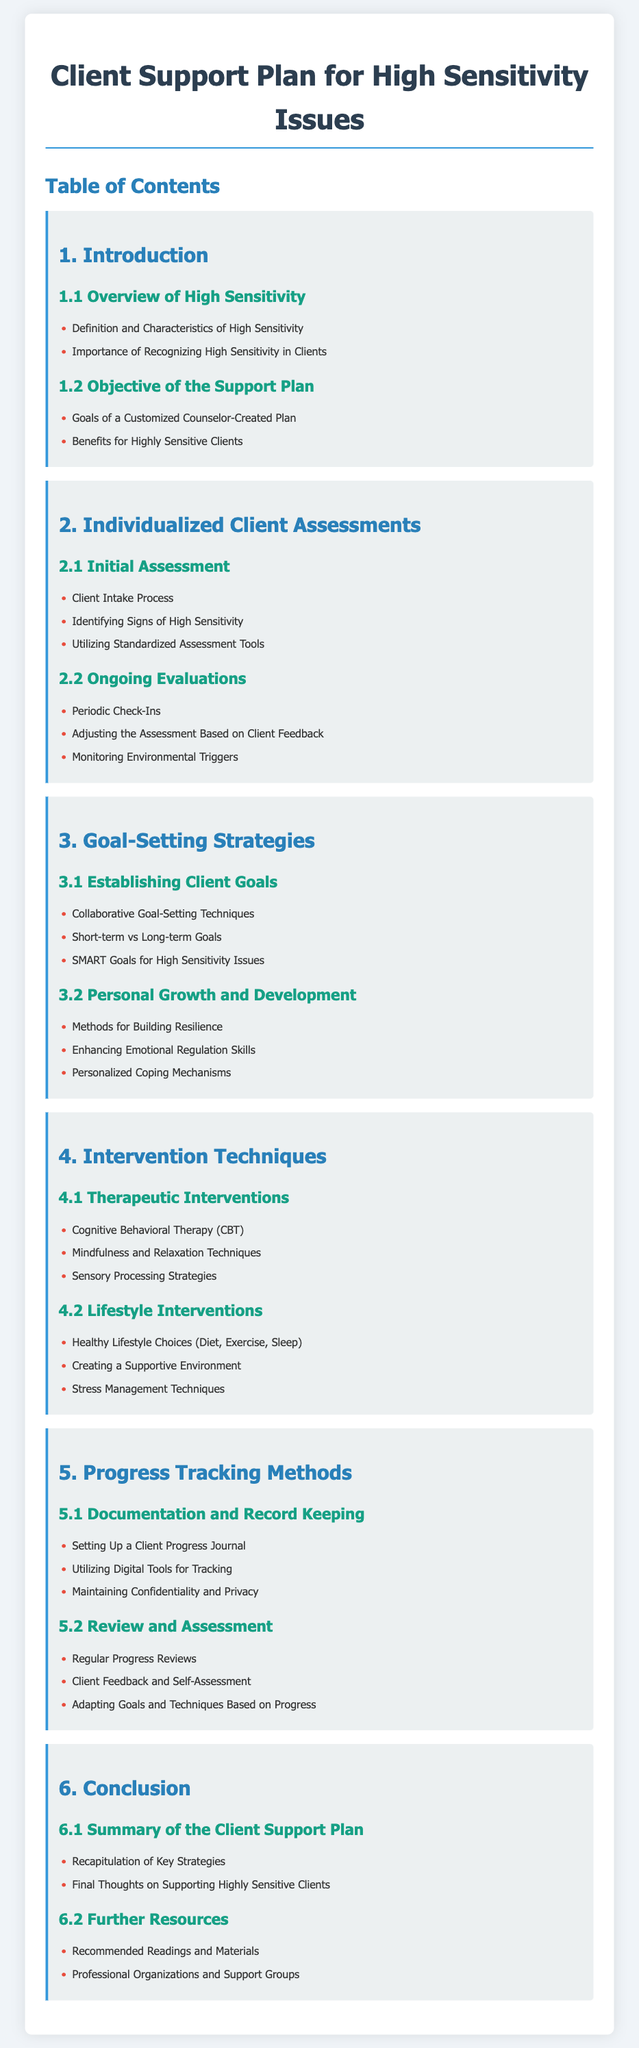What is the title of the document? The title is prominently displayed at the top of the document, indicating the primary focus of the content.
Answer: Client Support Plan for High Sensitivity Issues What section discusses initial assessments? The section pertaining to initial assessments can be found under Individualized Client Assessments.
Answer: 2.1 Initial Assessment How many main sections are included in the Table of Contents? The document contains a total of six main sections, which can be counted under the Table of Contents.
Answer: 6 What are SMART Goals? SMART Goals are a key concept in goal-setting strategies outlined in the document, particularly tailored for high sensitivity issues.
Answer: Specific, Measurable, Achievable, Relevant, Time-bound Which intervention technique is specifically mentioned for stress management? The document lists specific therapeutic and lifestyle interventions, with stress management techniques highlighted in the context of lifestyle interventions.
Answer: Stress Management Techniques What is the purpose of the progress tracking methods discussed? The purpose is focused on ensuring client development and proper documentation throughout the counseling process.
Answer: Documentation and Record Keeping What is mentioned as a benefit for highly sensitive clients? Benefits for highly sensitive clients are discussed in the objectives of the support plan, emphasizing the importance of tailored approaches.
Answer: Benefits for Highly Sensitive Clients Which techniques are included under Therapeutic Interventions? The document lists several therapeutic interventions, including the most impactful techniques for supporting clients with high sensitivity.
Answer: Cognitive Behavioral Therapy (CBT) What is included in the further resources section? This section provides additional support material and guidance for counselors working with sensitive clients.
Answer: Recommended Readings and Materials 